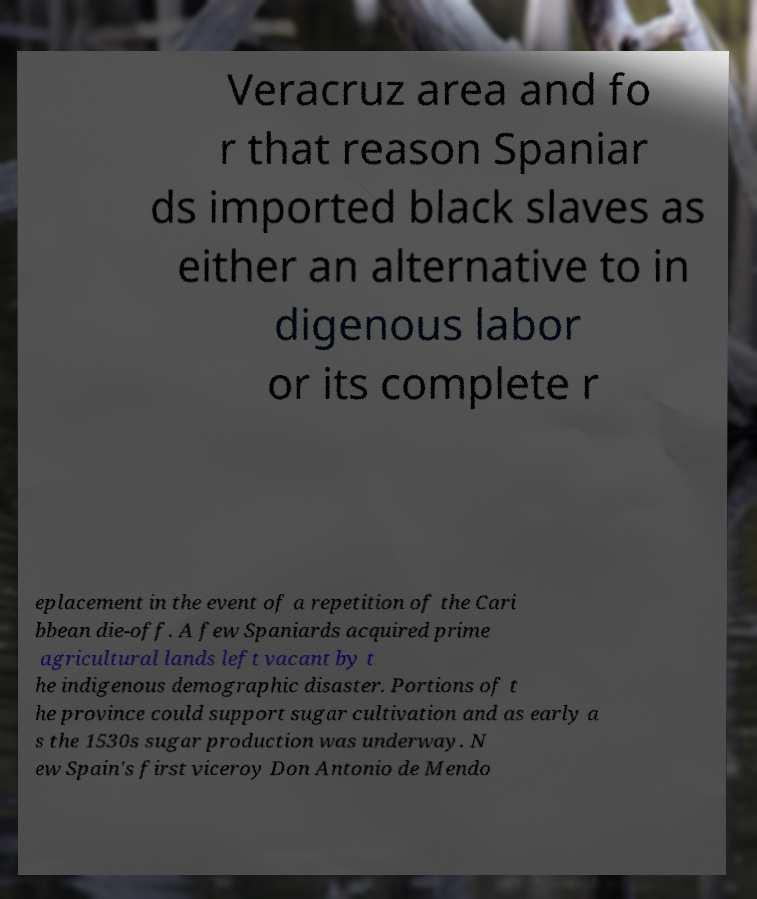Could you extract and type out the text from this image? Veracruz area and fo r that reason Spaniar ds imported black slaves as either an alternative to in digenous labor or its complete r eplacement in the event of a repetition of the Cari bbean die-off. A few Spaniards acquired prime agricultural lands left vacant by t he indigenous demographic disaster. Portions of t he province could support sugar cultivation and as early a s the 1530s sugar production was underway. N ew Spain's first viceroy Don Antonio de Mendo 